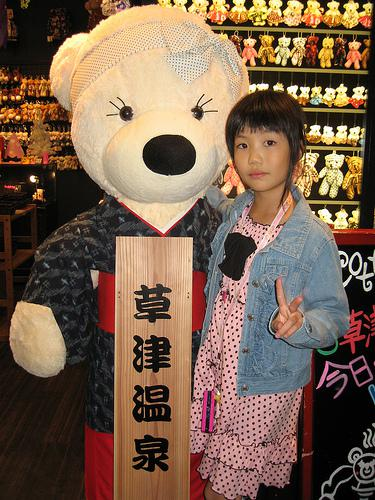Question: who is holding up a peace sign?
Choices:
A. A girl.
B. A boy.
C. A man.
D. A woman.
Answer with the letter. Answer: A Question: what is pictured behind the pair?
Choices:
A. Large stuffed animals.
B. Cars.
C. Trucks.
D. Small stuffed animals.
Answer with the letter. Answer: D Question: what pattern is on the girl's dress?
Choices:
A. Stripes.
B. Plaid.
C. Solid.
D. Polka dots.
Answer with the letter. Answer: D Question: what type of jacket is the girl wearing?
Choices:
A. Down.
B. Flannel.
C. Leather.
D. Denim.
Answer with the letter. Answer: D Question: what culture is depicted?
Choices:
A. Chinese.
B. Korean.
C. Japanese.
D. Vietnamese.
Answer with the letter. Answer: C 